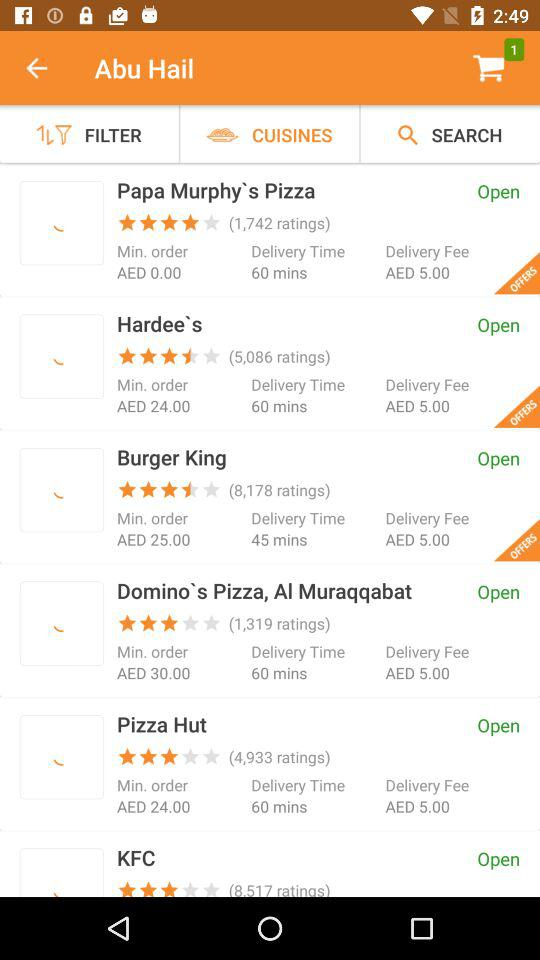Which restaurant has the highest customer rating?
Answer the question using a single word or phrase. Papa Murphy's Pizza 